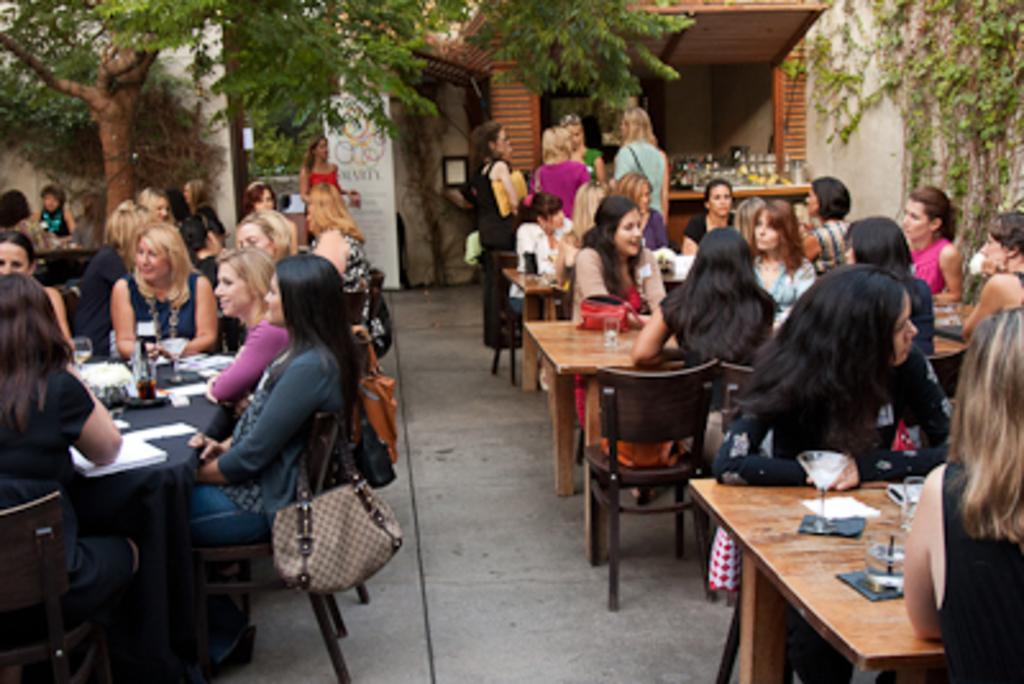Please provide a concise description of this image. In this picture there are two rows of tables one is at right side and other is at left side, there are some people those who are sitting on the chairs, it seems to be they are discussing something in the image, there is a canteen at the right side of the image and there are some trees around the image, they all are ladies in the image, some ladies are standing at the right side of the image, there are some glasses, papers and tissues on the tables. 